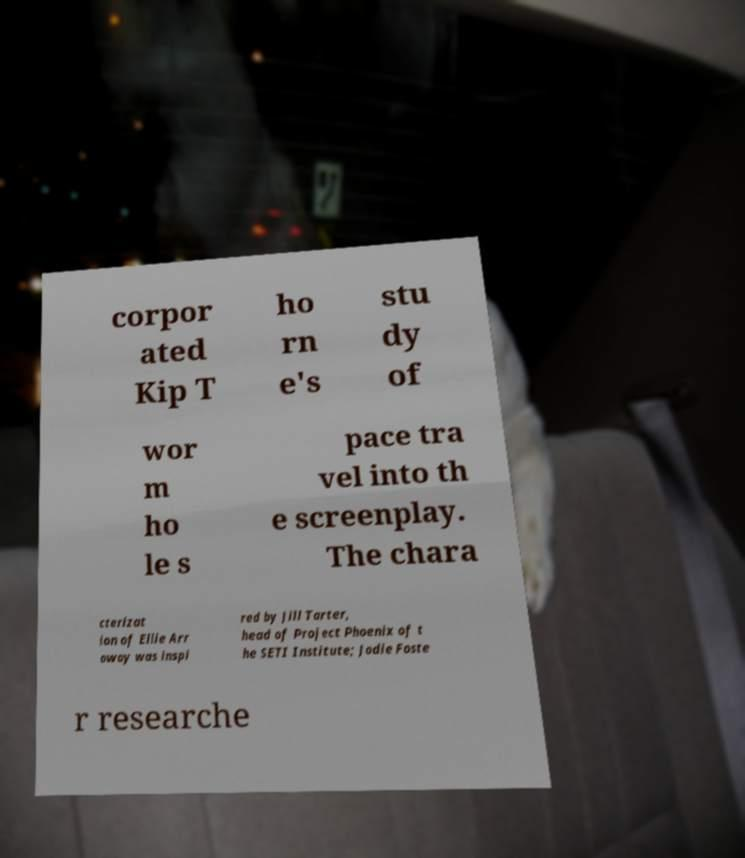What messages or text are displayed in this image? I need them in a readable, typed format. corpor ated Kip T ho rn e's stu dy of wor m ho le s pace tra vel into th e screenplay. The chara cterizat ion of Ellie Arr oway was inspi red by Jill Tarter, head of Project Phoenix of t he SETI Institute; Jodie Foste r researche 